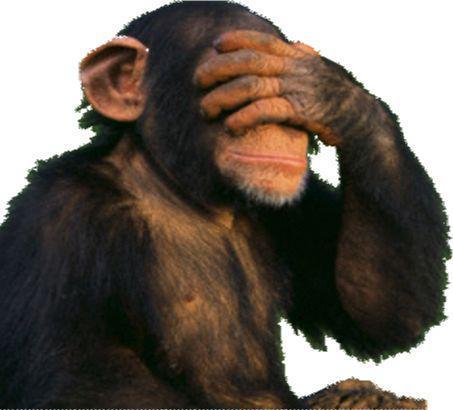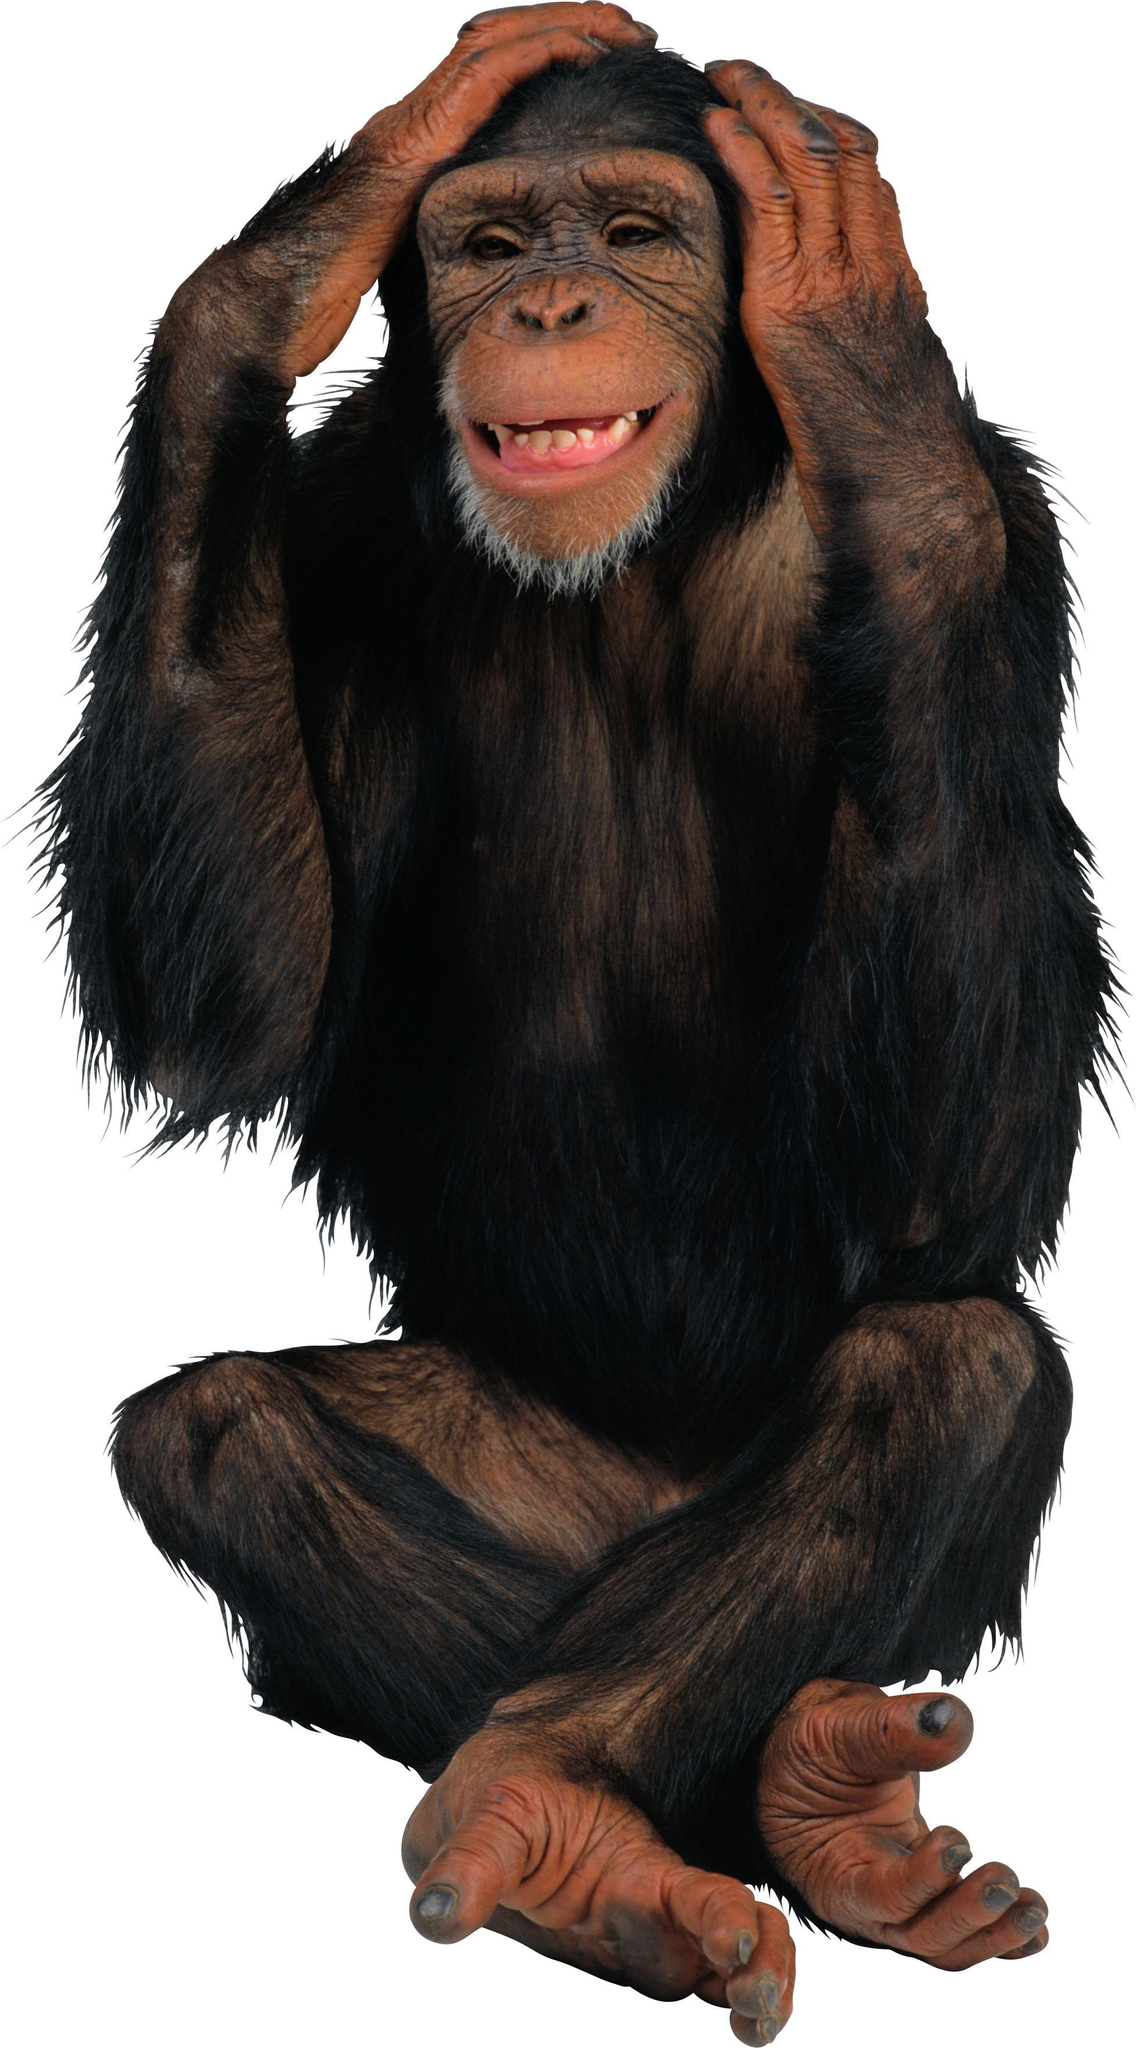The first image is the image on the left, the second image is the image on the right. Evaluate the accuracy of this statement regarding the images: "A primate is being shown against a black background.". Is it true? Answer yes or no. No. The first image is the image on the left, the second image is the image on the right. Evaluate the accuracy of this statement regarding the images: "Each image shows exactly one chimpanzee, with at least one of its hands touching part of its body.". Is it true? Answer yes or no. Yes. 